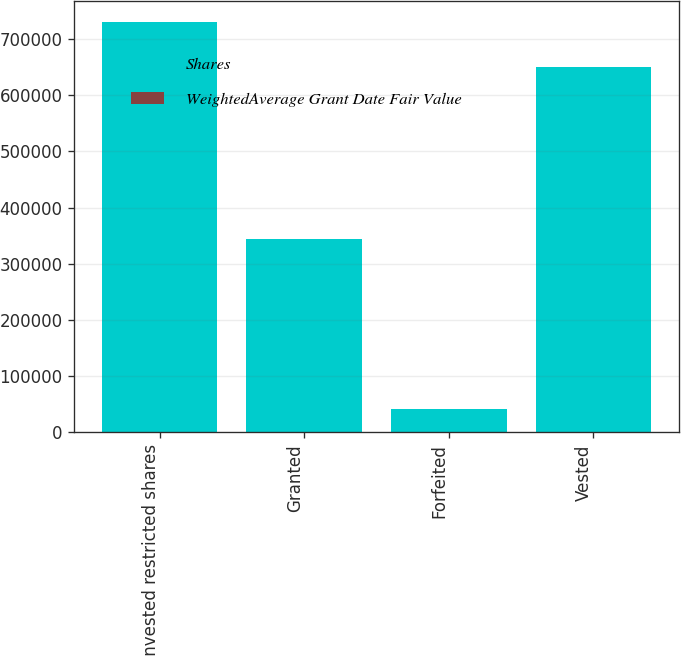Convert chart to OTSL. <chart><loc_0><loc_0><loc_500><loc_500><stacked_bar_chart><ecel><fcel>Unvested restricted shares<fcel>Granted<fcel>Forfeited<fcel>Vested<nl><fcel>Shares<fcel>730550<fcel>344812<fcel>41684<fcel>649363<nl><fcel>WeightedAverage Grant Date Fair Value<fcel>18.03<fcel>14.66<fcel>14.34<fcel>13.79<nl></chart> 